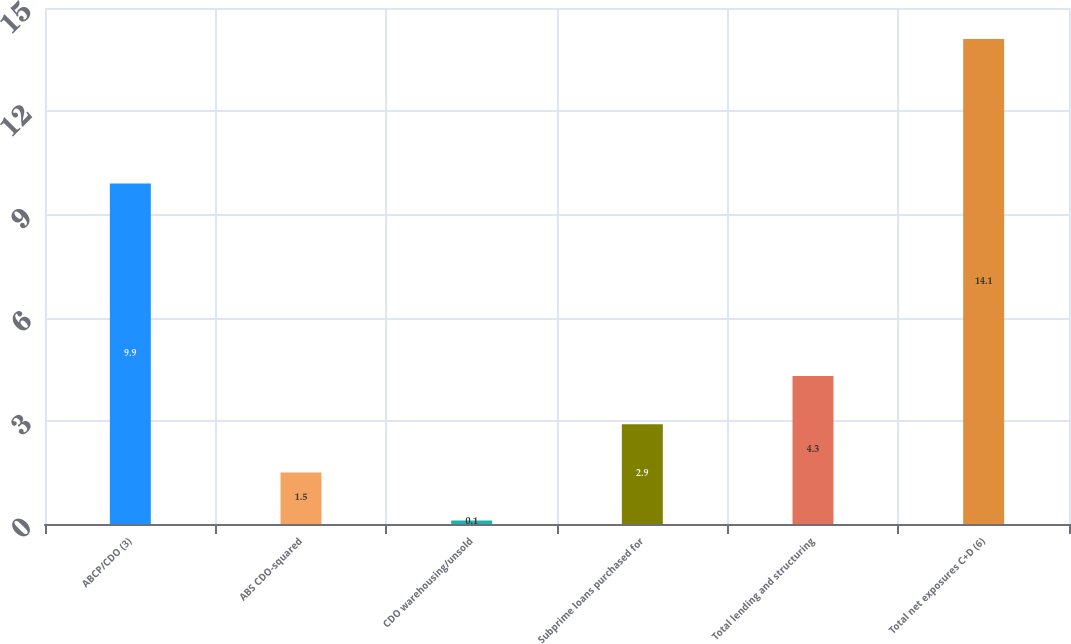<chart> <loc_0><loc_0><loc_500><loc_500><bar_chart><fcel>ABCP/CDO (3)<fcel>ABS CDO-squared<fcel>CDO warehousing/unsold<fcel>Subprime loans purchased for<fcel>Total lending and structuring<fcel>Total net exposures C+D (6)<nl><fcel>9.9<fcel>1.5<fcel>0.1<fcel>2.9<fcel>4.3<fcel>14.1<nl></chart> 